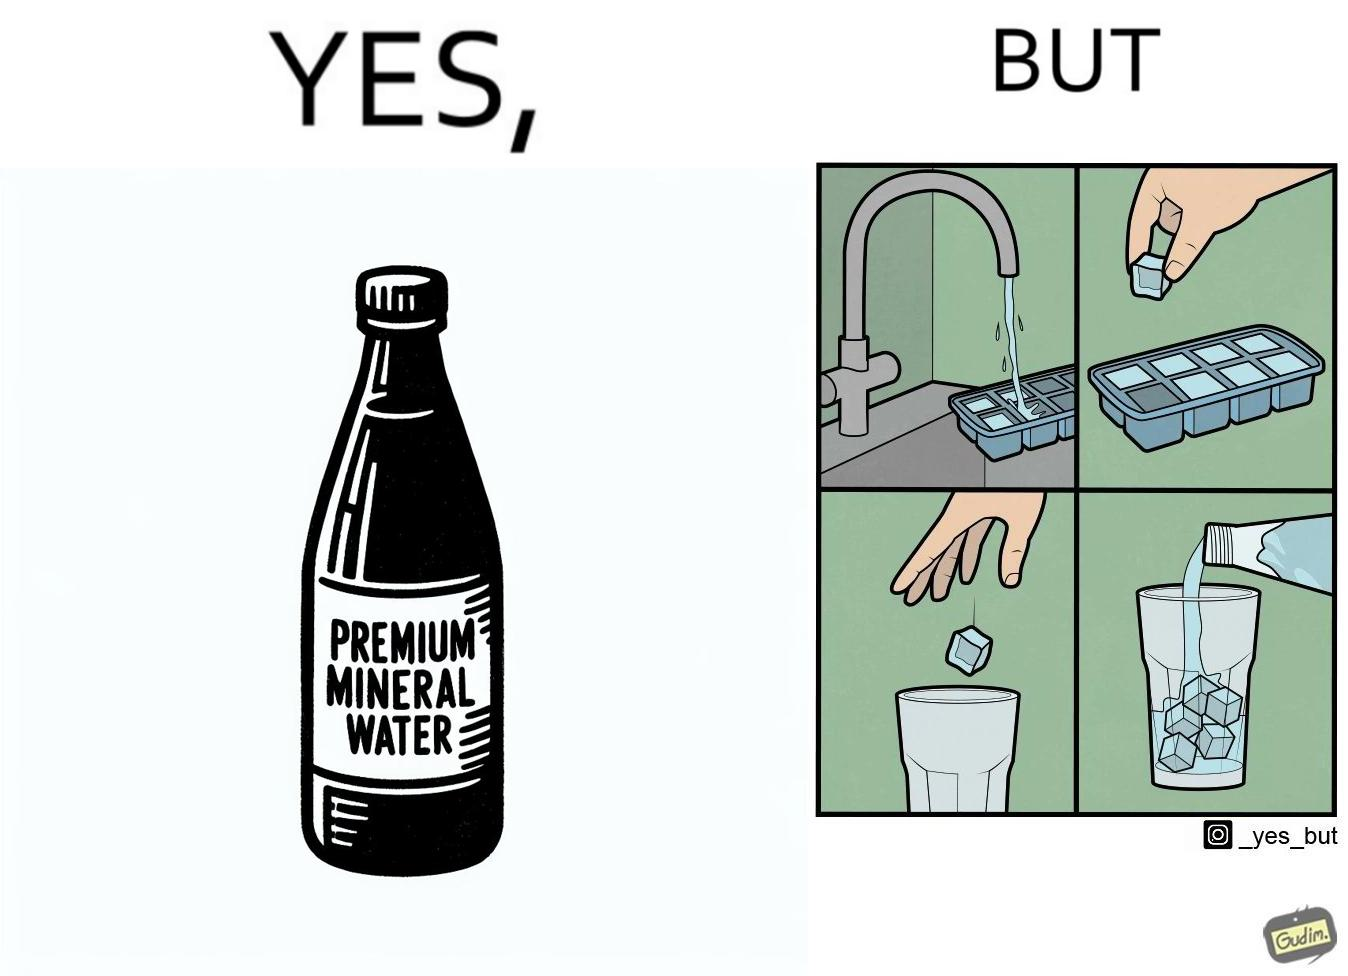Describe the content of this image. This image is ironical, as a bottle of mineral water is being used along with ice cubes from tap water, while the sama tap water could have been instead used. 